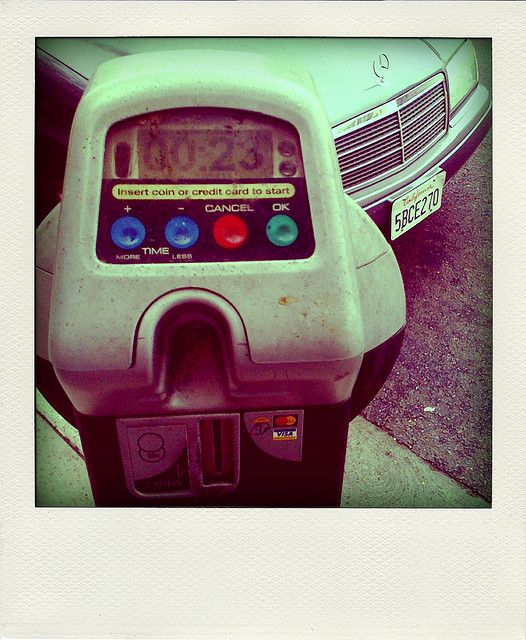Please transcribe the text information in this image. Start 23 CANCEL OK TIME 5BCE270 00:23 MORE to card Credit ol coln Insert 